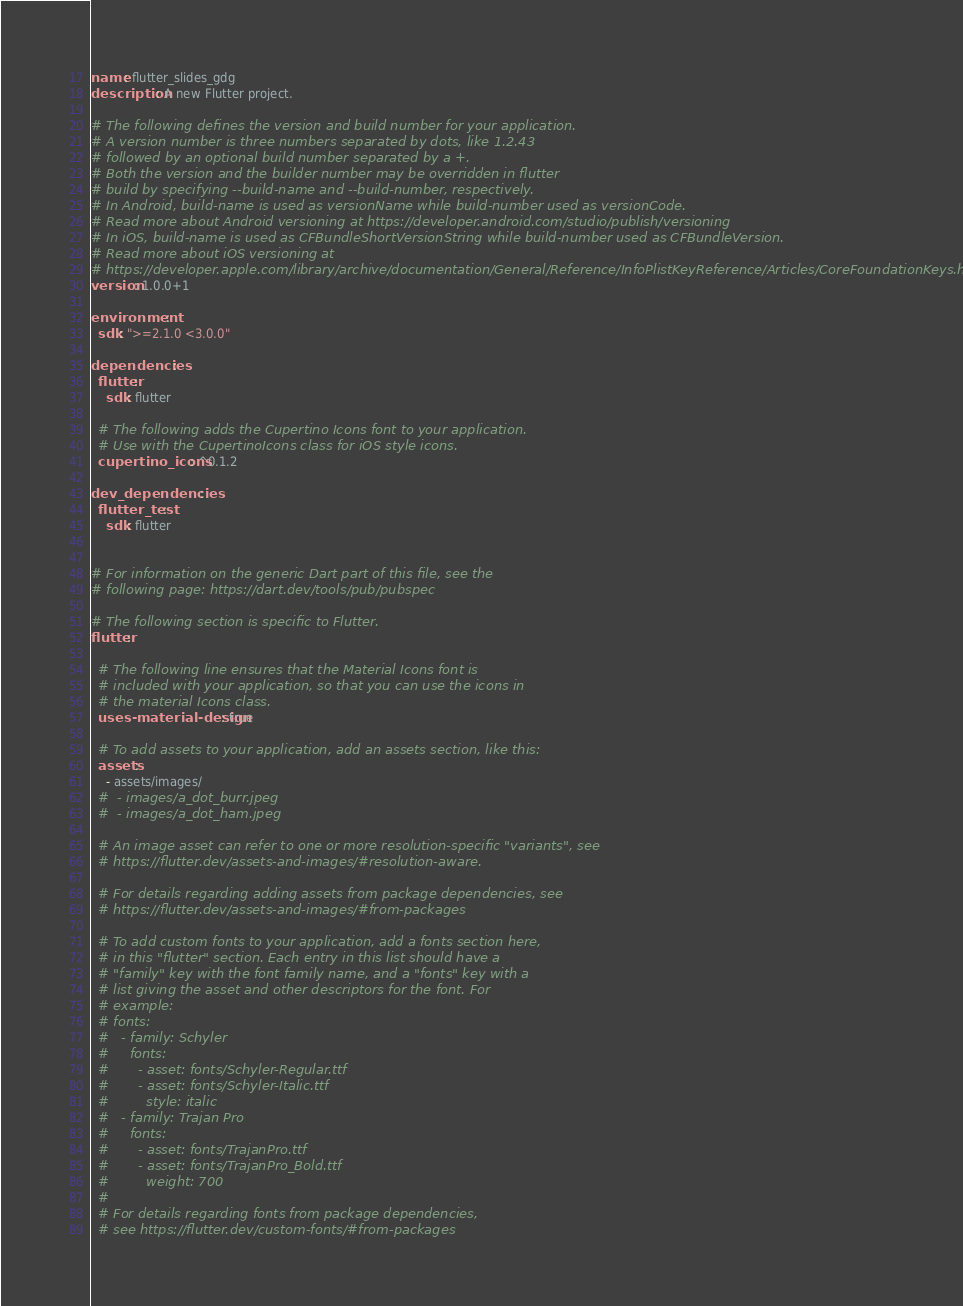Convert code to text. <code><loc_0><loc_0><loc_500><loc_500><_YAML_>name: flutter_slides_gdg
description: A new Flutter project.

# The following defines the version and build number for your application.
# A version number is three numbers separated by dots, like 1.2.43
# followed by an optional build number separated by a +.
# Both the version and the builder number may be overridden in flutter
# build by specifying --build-name and --build-number, respectively.
# In Android, build-name is used as versionName while build-number used as versionCode.
# Read more about Android versioning at https://developer.android.com/studio/publish/versioning
# In iOS, build-name is used as CFBundleShortVersionString while build-number used as CFBundleVersion.
# Read more about iOS versioning at
# https://developer.apple.com/library/archive/documentation/General/Reference/InfoPlistKeyReference/Articles/CoreFoundationKeys.html
version: 1.0.0+1

environment:
  sdk: ">=2.1.0 <3.0.0"

dependencies:
  flutter:
    sdk: flutter

  # The following adds the Cupertino Icons font to your application.
  # Use with the CupertinoIcons class for iOS style icons.
  cupertino_icons: ^0.1.2

dev_dependencies:
  flutter_test:
    sdk: flutter


# For information on the generic Dart part of this file, see the
# following page: https://dart.dev/tools/pub/pubspec

# The following section is specific to Flutter.
flutter:

  # The following line ensures that the Material Icons font is
  # included with your application, so that you can use the icons in
  # the material Icons class.
  uses-material-design: true

  # To add assets to your application, add an assets section, like this:
  assets:
    - assets/images/
  #  - images/a_dot_burr.jpeg
  #  - images/a_dot_ham.jpeg

  # An image asset can refer to one or more resolution-specific "variants", see
  # https://flutter.dev/assets-and-images/#resolution-aware.

  # For details regarding adding assets from package dependencies, see
  # https://flutter.dev/assets-and-images/#from-packages

  # To add custom fonts to your application, add a fonts section here,
  # in this "flutter" section. Each entry in this list should have a
  # "family" key with the font family name, and a "fonts" key with a
  # list giving the asset and other descriptors for the font. For
  # example:
  # fonts:
  #   - family: Schyler
  #     fonts:
  #       - asset: fonts/Schyler-Regular.ttf
  #       - asset: fonts/Schyler-Italic.ttf
  #         style: italic
  #   - family: Trajan Pro
  #     fonts:
  #       - asset: fonts/TrajanPro.ttf
  #       - asset: fonts/TrajanPro_Bold.ttf
  #         weight: 700
  #
  # For details regarding fonts from package dependencies,
  # see https://flutter.dev/custom-fonts/#from-packages
</code> 